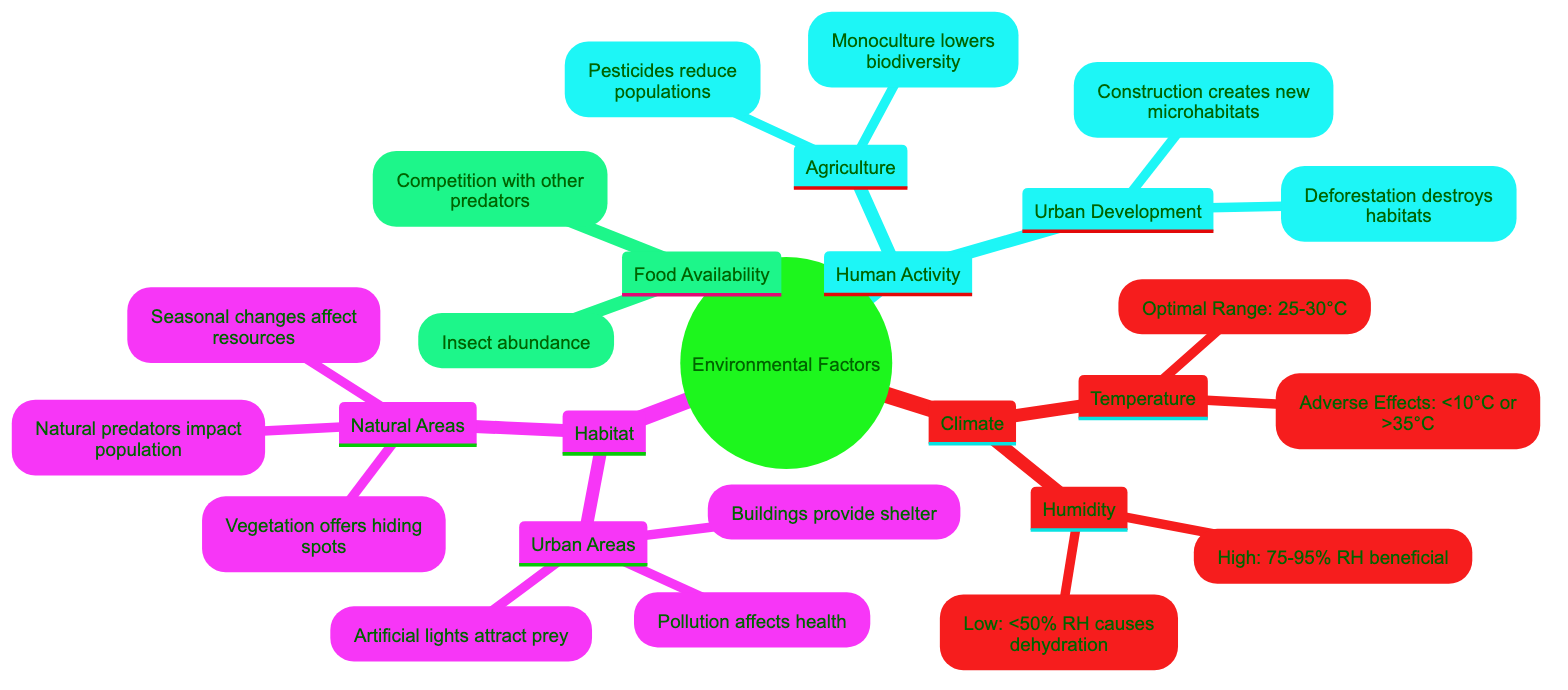What is the optimal temperature range for spiders? The diagram indicates that the optimal temperature range for spiders is 25-30°C under the Temperature section of the Climate node.
Answer: 25-30°C What are the adverse temperature effects on spiders? According to the same Temperature section, the adverse effects specified are below 10°C or above 35°C, which decrease spider activity.
Answer: Below 10°C or above 35°C What humidity level is beneficial for spiders? The diagram states that a high humidity level of 75-95% RH is beneficial for spider's web and prey capture under the Humidity section.
Answer: 75-95% RH What factors from human activity can reduce spider populations? The diagram mentions that both pesticides and monoculture used in Agriculture can reduce spider populations, and deforestation in Urban Development also leads to habitat loss, impacting spiders.
Answer: Pesticides, monoculture, deforestation What effect does vegetation density have on spiders in natural areas? The diagram notes that high vegetation density offers more hiding spots and prey, which positively influences spider survival in the Natural Areas habitat.
Answer: More hiding spots and prey How does urban lighting affect spider populations? Urban lighting is specified in the diagram as attracting prey insects, thereby benefiting spider populations by increasing food availability.
Answer: Attracts prey insects How do seasonal changes impact spider populations? In the Natural Areas habitat section, it is mentioned that seasonal changes affect the availability of prey and shelter, which are crucial for spider survival.
Answer: Affect availability of prey and shelter What is the relationship between pollution and spider health? The diagram indicates under Urban Areas that pollution can reduce prey availability and spider health, linking human activity directly to environmental impacts.
Answer: Reduces prey availability and health What is a consequence of agriculture on spider food sources? Monoculture, as stated under Agricultural practices in the Human Activity section, can lower biodiversity, which leads to a decrease in the availability of prey for spiders.
Answer: Lowers biodiversity, affecting prey availability 